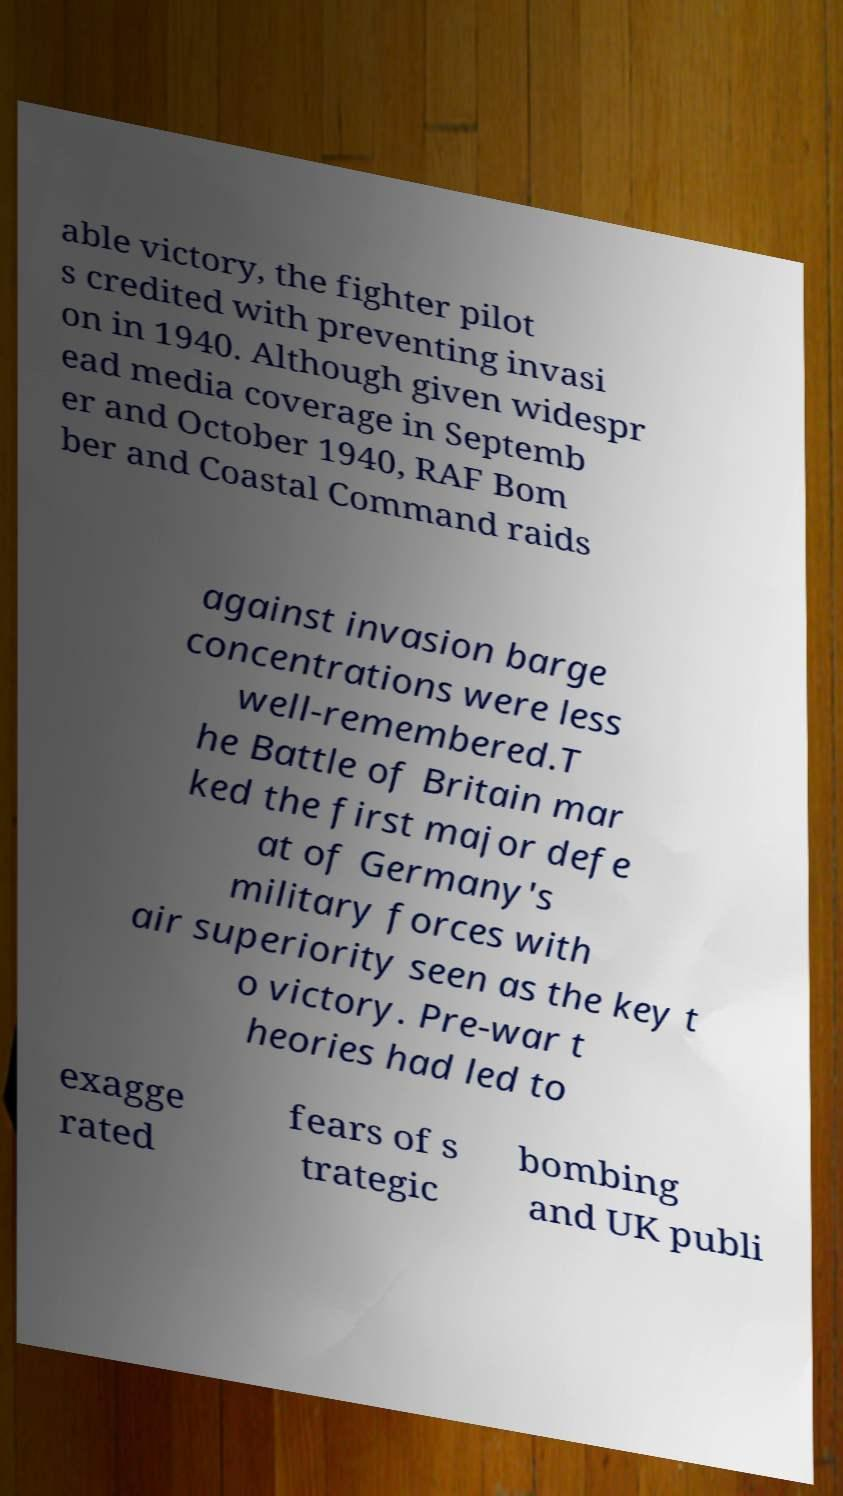Can you accurately transcribe the text from the provided image for me? able victory, the fighter pilot s credited with preventing invasi on in 1940. Although given widespr ead media coverage in Septemb er and October 1940, RAF Bom ber and Coastal Command raids against invasion barge concentrations were less well-remembered.T he Battle of Britain mar ked the first major defe at of Germany's military forces with air superiority seen as the key t o victory. Pre-war t heories had led to exagge rated fears of s trategic bombing and UK publi 